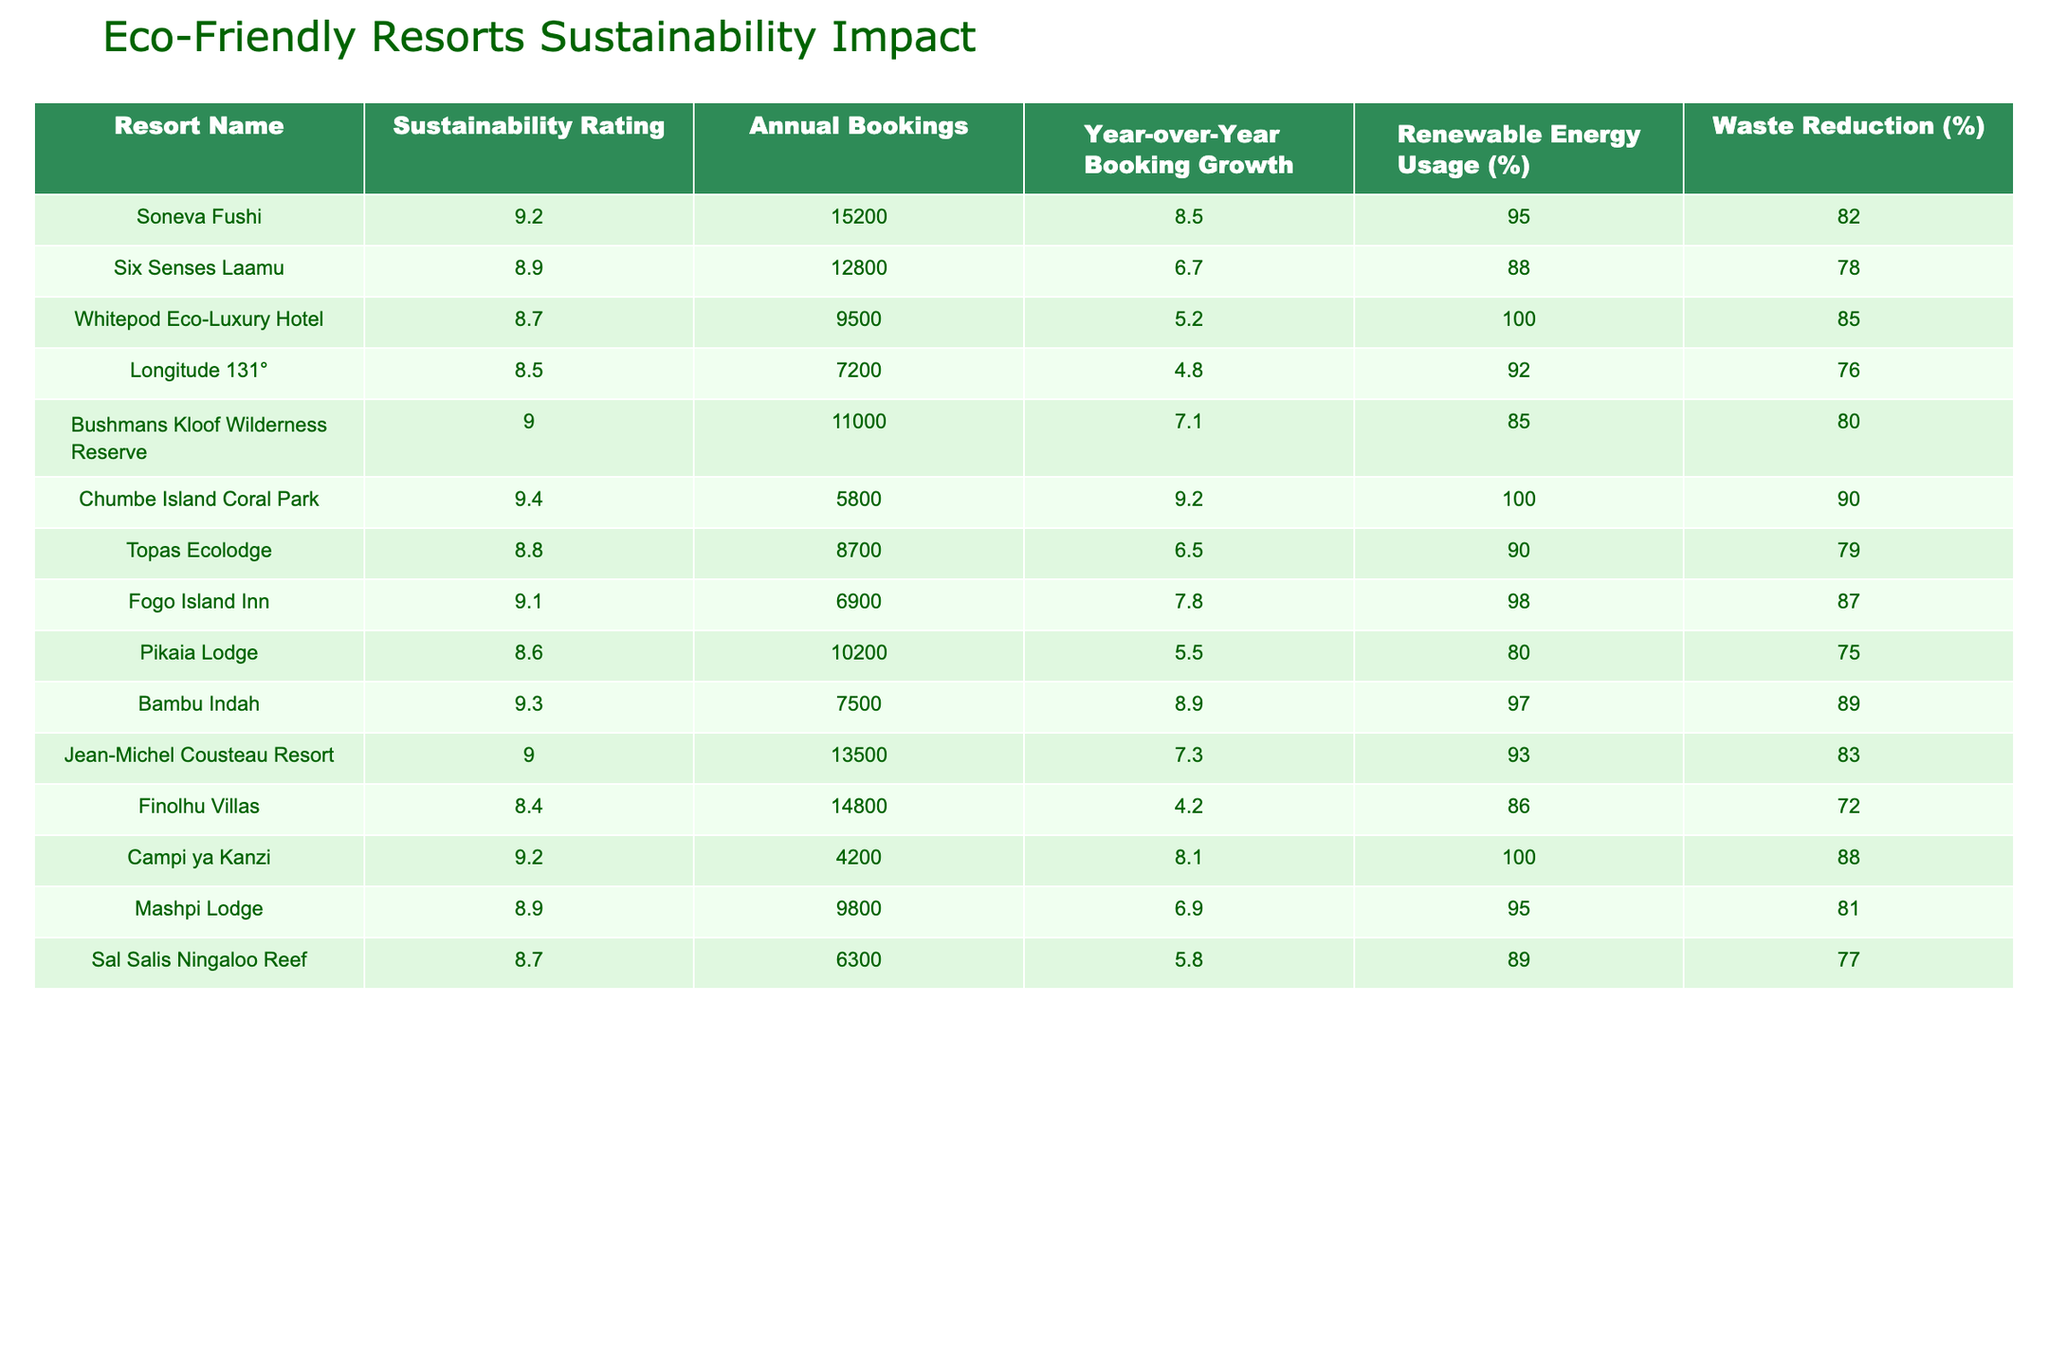What is the Sustainability Rating of Soneva Fushi? The table lists Soneva Fushi's Sustainability Rating, which is found in the corresponding column. The value for Soneva Fushi is 9.2.
Answer: 9.2 Which resort has the highest Annual Bookings? By examining the Annual Bookings column, it shows that Soneva Fushi has the highest total of 15,200 bookings compared to other resorts.
Answer: Soneva Fushi What is the difference in Renewable Energy Usage between Chumbe Island Coral Park and Finolhu Villas? The Renewable Energy Usage for Chumbe Island Coral Park is 100% and for Finolhu Villas is 86%. The difference is 100% - 86% = 14%.
Answer: 14% Is the Waste Reduction percentage of Topas Ecolodge greater than 80%? Looking at Topas Ecolodge’s Waste Reduction percentage, which is noted as 79%, it is less than 80%. Thus, the answer is no.
Answer: No What is the average Sustainability Rating of the resorts listed? To find the average, sum all the Sustainability Ratings: 9.2 + 8.9 + 8.7 + 8.5 + 9.0 + 9.4 + 8.8 + 9.1 + 8.6 + 9.3 + 9.0 + 8.4 + 9.2 + 8.9 + 8.7 = 135.8. Then, divide by the number of resorts, which is 15: 135.8 / 15 = 9.0533. The average Sustainability Rating is approximately 9.05.
Answer: 9.05 Which resort shows the highest Year-over-Year Booking Growth? Looking at the Year-over-Year Booking Growth column, the highest value listed is 9.2%, which belongs to Chumbe Island Coral Park.
Answer: Chumbe Island Coral Park How many resorts have a Sustainability Rating above 9.0? By counting the entries in the Sustainability Rating column that are above 9.0, the resorts meeting this criteria are Soneva Fushi, Bushmans Kloof Wilderness Reserve, Chumbe Island Coral Park, Bambu Indah, and Campi ya Kanzi. This yields a total of 5 resorts.
Answer: 5 What percentage of Waste Reduction does the resort with the lowest Sustainability Rating achieve? The resort with the lowest Sustainability Rating is Finolhu Villas, with a rating of 8.4, and its Waste Reduction percentage is 72%.
Answer: 72% If the sum of Annual Bookings for all resorts is less than 100,000, true or false? Summing the Annual Bookings: 15200 + 12800 + 9500 + 7200 + 11000 + 5800 + 8700 + 6900 + 10200 + 7500 + 13500 + 14800 + 4200 + 9800 + 6300 = 108,500, which exceeds 100,000. Therefore, the statement is false.
Answer: False What is the Renewable Energy Usage for resorts with a Sustainability Rating below 9.0? Listing the Renewable Energy Usage for resorts below a 9.0 rating: Longitude 131° (92%), Topas Ecolodge (90%), Pikaia Lodge (80%), Finolhu Villas (86%), and Sal Salis Ningaloo Reef (89%). The average of these values is (92 + 90 + 80 + 86 + 89) / 5 = 87.4%.
Answer: 87.4% 